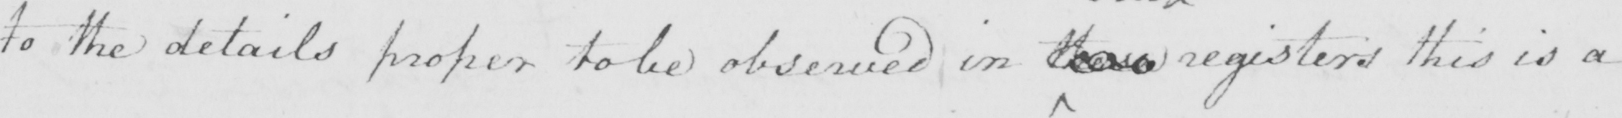Please provide the text content of this handwritten line. to the details proper to be observed in those registers this is a 